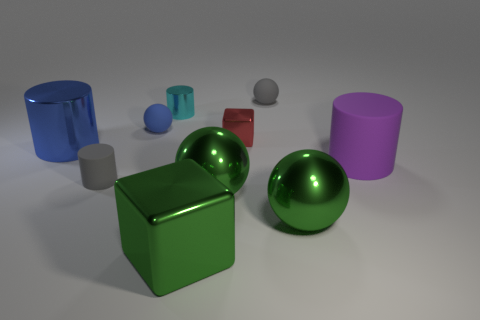Subtract all gray spheres. How many spheres are left? 3 Subtract all balls. How many objects are left? 6 Subtract 0 cyan cubes. How many objects are left? 10 Subtract all metal things. Subtract all small cyan matte cubes. How many objects are left? 4 Add 9 green metallic blocks. How many green metallic blocks are left? 10 Add 2 large green cubes. How many large green cubes exist? 3 